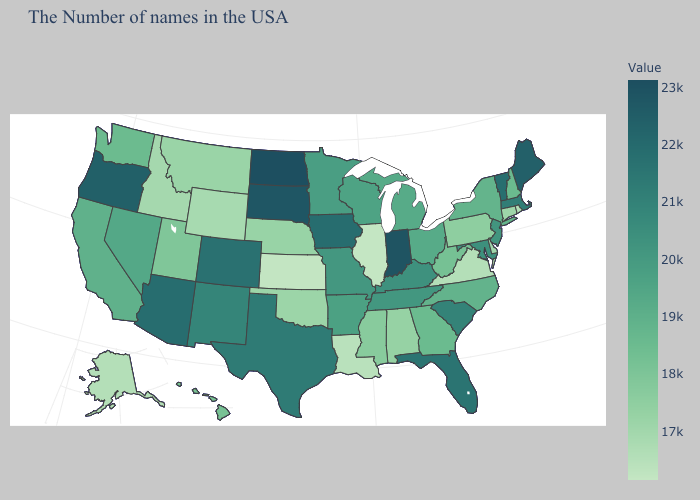Does Florida have the highest value in the South?
Quick response, please. Yes. Which states hav the highest value in the South?
Quick response, please. Florida. Among the states that border New Jersey , does New York have the highest value?
Give a very brief answer. Yes. Among the states that border Connecticut , does Rhode Island have the lowest value?
Write a very short answer. Yes. 